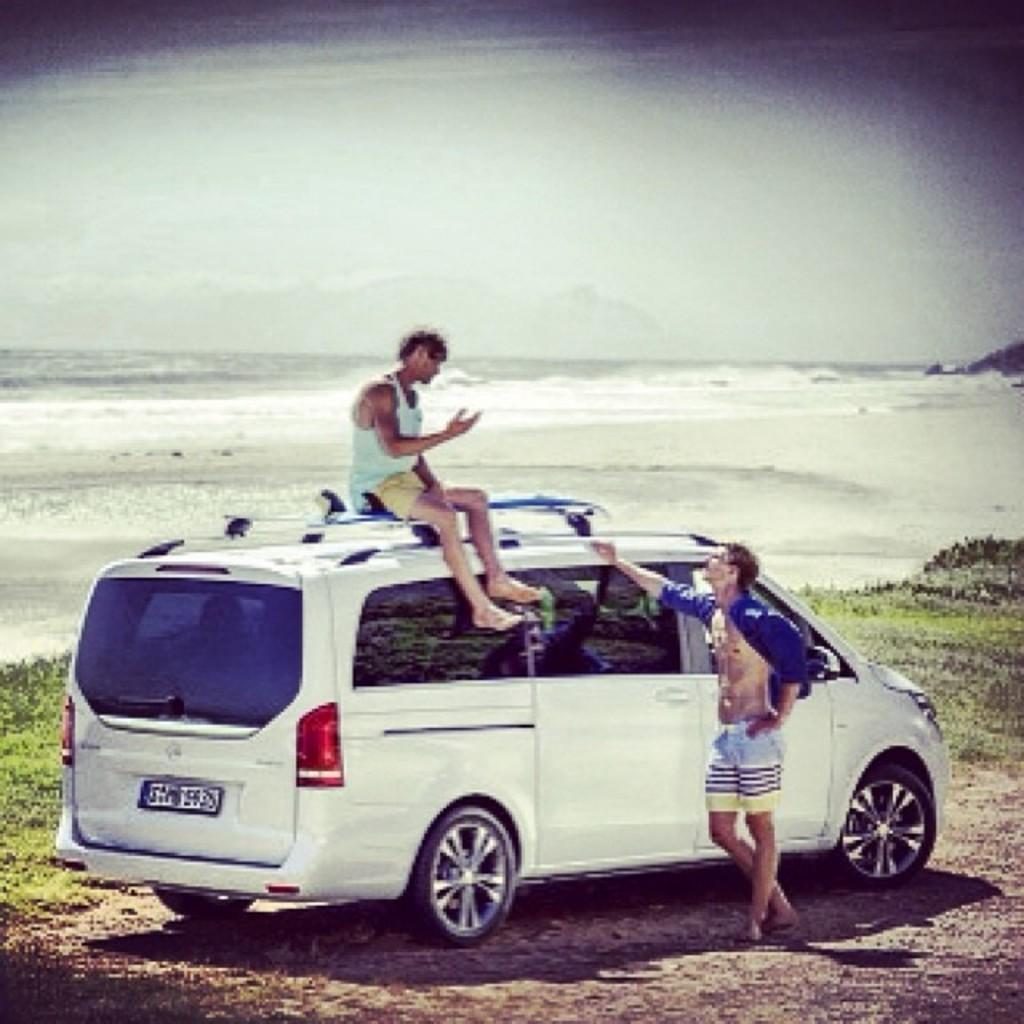Could you give a brief overview of what you see in this image? In this image we can see two people, one among them is sitting on the car and the other one is standing beside it, in the background there is a sea. 